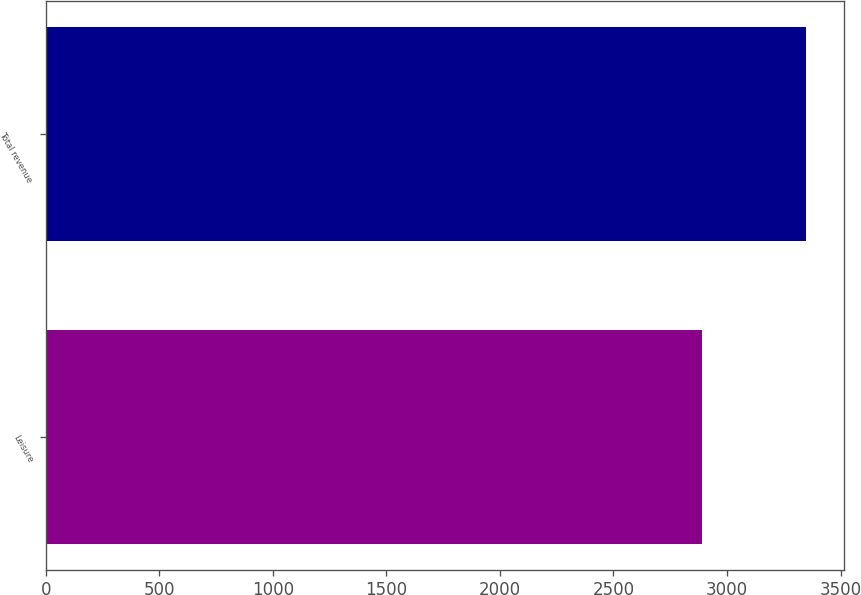<chart> <loc_0><loc_0><loc_500><loc_500><bar_chart><fcel>Leisure<fcel>Total revenue<nl><fcel>2891<fcel>3348<nl></chart> 